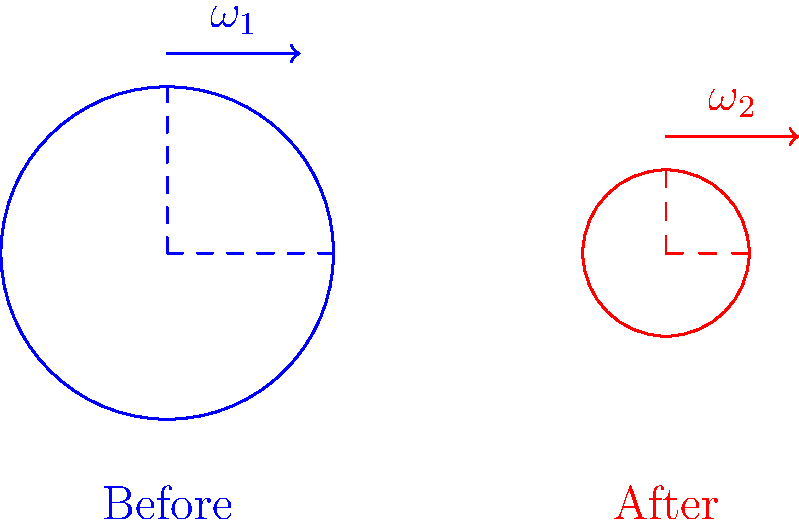A ballet dancer starts a pirouette with their arms extended and then pulls them close to their body. If the initial angular velocity is $\omega_1$ and the moment of inertia changes from $I_1$ to $I_2$, what is the final angular velocity $\omega_2$ in terms of $\omega_1$, $I_1$, and $I_2$? To solve this problem, we'll use the principle of conservation of angular momentum:

1. Angular momentum is conserved in the absence of external torques.
2. Angular momentum (L) is the product of moment of inertia (I) and angular velocity ($\omega$).
3. Initial angular momentum: $L_1 = I_1\omega_1$
4. Final angular momentum: $L_2 = I_2\omega_2$
5. Since angular momentum is conserved: $L_1 = L_2$
6. Therefore: $I_1\omega_1 = I_2\omega_2$
7. Solving for $\omega_2$: $\omega_2 = \frac{I_1\omega_1}{I_2}$

This equation shows that as the moment of inertia decreases (arms pulled in), the angular velocity increases, demonstrating the spectacular increase in rotation speed observed in pirouettes.
Answer: $\omega_2 = \frac{I_1\omega_1}{I_2}$ 